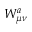Convert formula to latex. <formula><loc_0><loc_0><loc_500><loc_500>W _ { \mu \nu } ^ { a }</formula> 